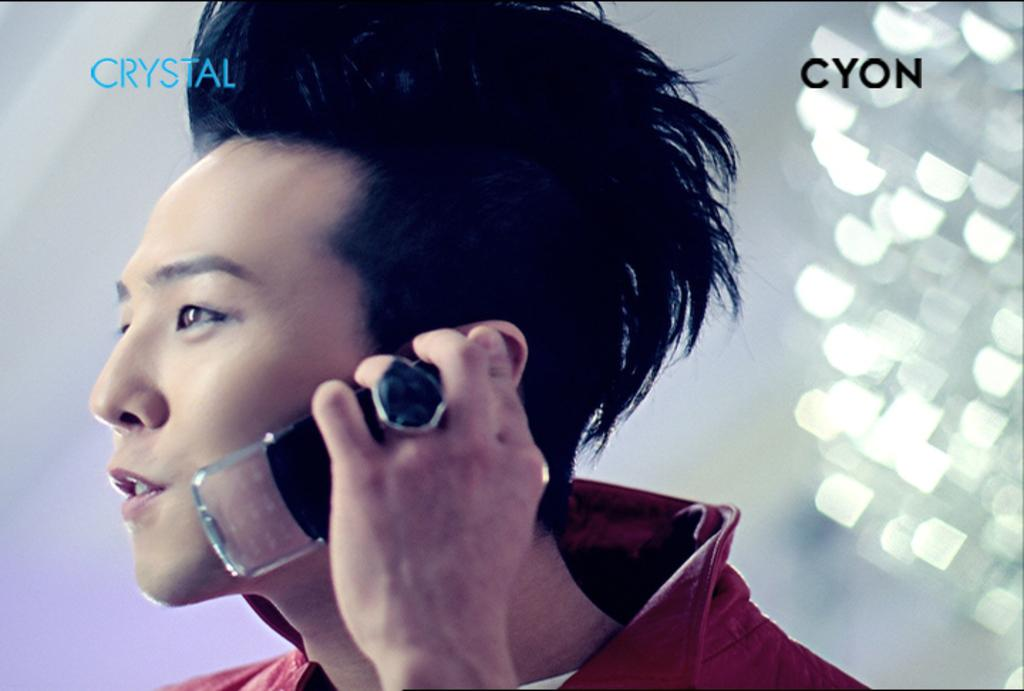<image>
Offer a succinct explanation of the picture presented. an ad for CYON Crystal with stylish person holding phone to ear 